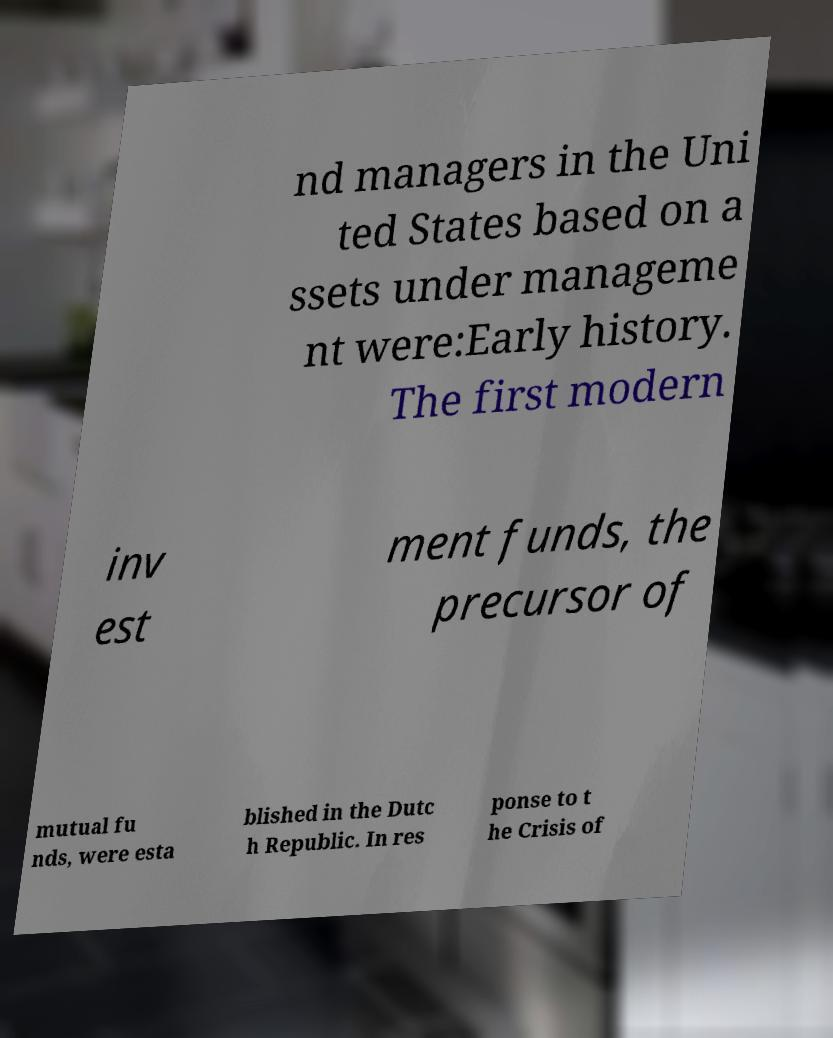Could you extract and type out the text from this image? nd managers in the Uni ted States based on a ssets under manageme nt were:Early history. The first modern inv est ment funds, the precursor of mutual fu nds, were esta blished in the Dutc h Republic. In res ponse to t he Crisis of 